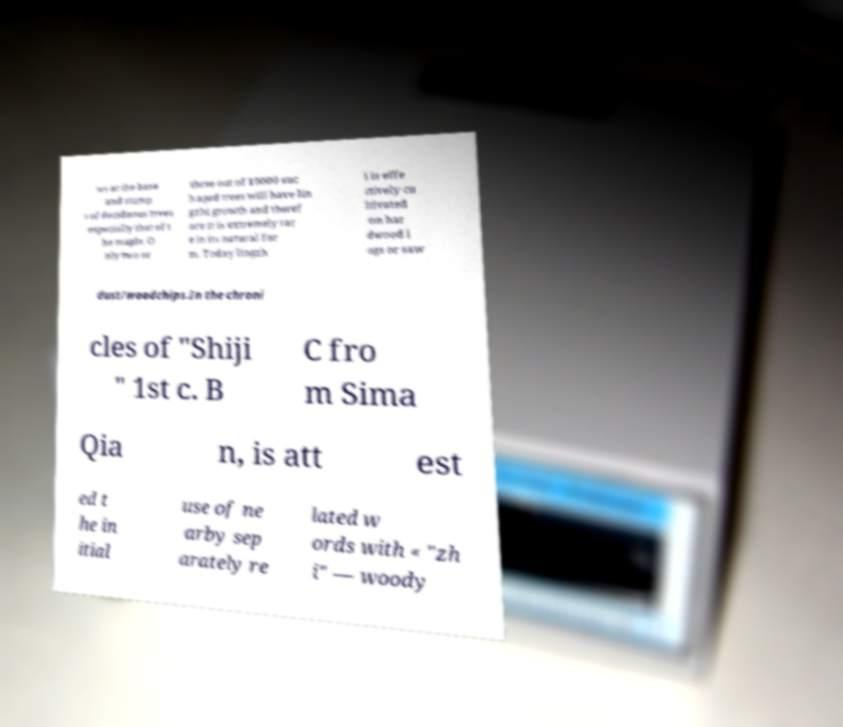There's text embedded in this image that I need extracted. Can you transcribe it verbatim? ws at the base and stump s of deciduous trees especially that of t he maple. O nly two or three out of 10000 suc h aged trees will have lin gzhi growth and theref ore it is extremely rar e in its natural for m. Today lingzh i is effe ctively cu ltivated on har dwood l ogs or saw dust/woodchips.In the chroni cles of "Shiji " 1st c. B C fro m Sima Qia n, is att est ed t he in itial use of ne arby sep arately re lated w ords with « "zh i" — woody 